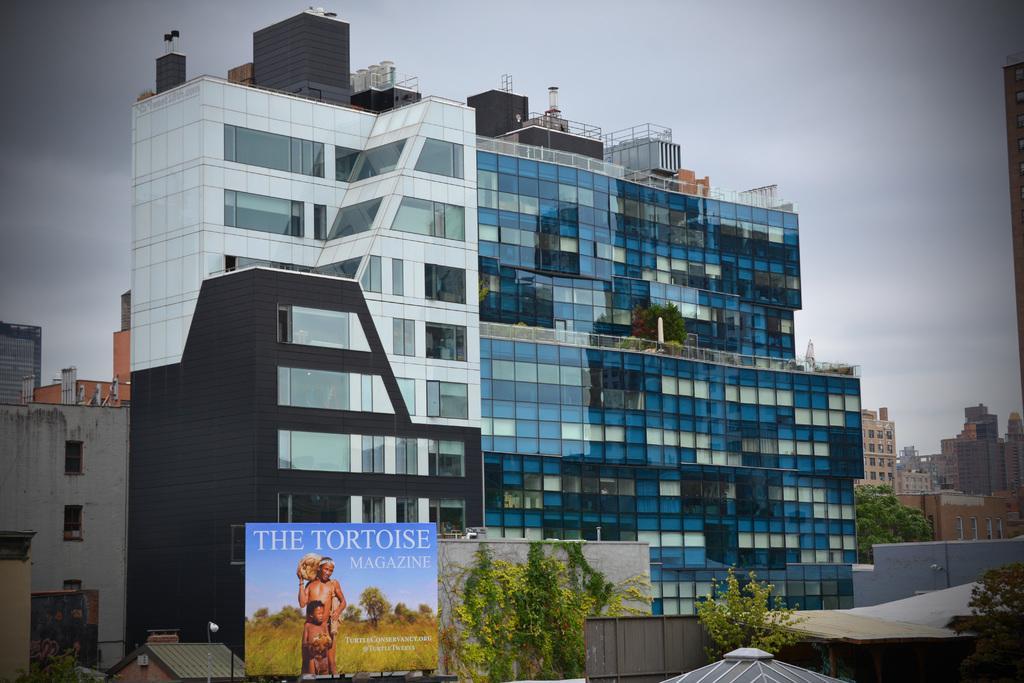How would you summarize this image in a sentence or two? In the image we can see the buildings and trees. Here we can see the poster, on the poster there is a text and the pictures of two people and the sky. 